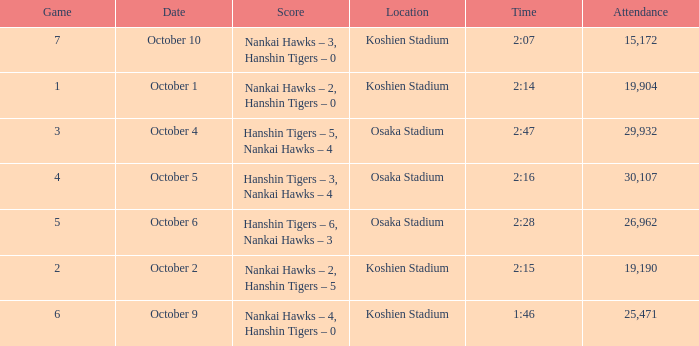How many games have an Attendance of 19,190? 1.0. 